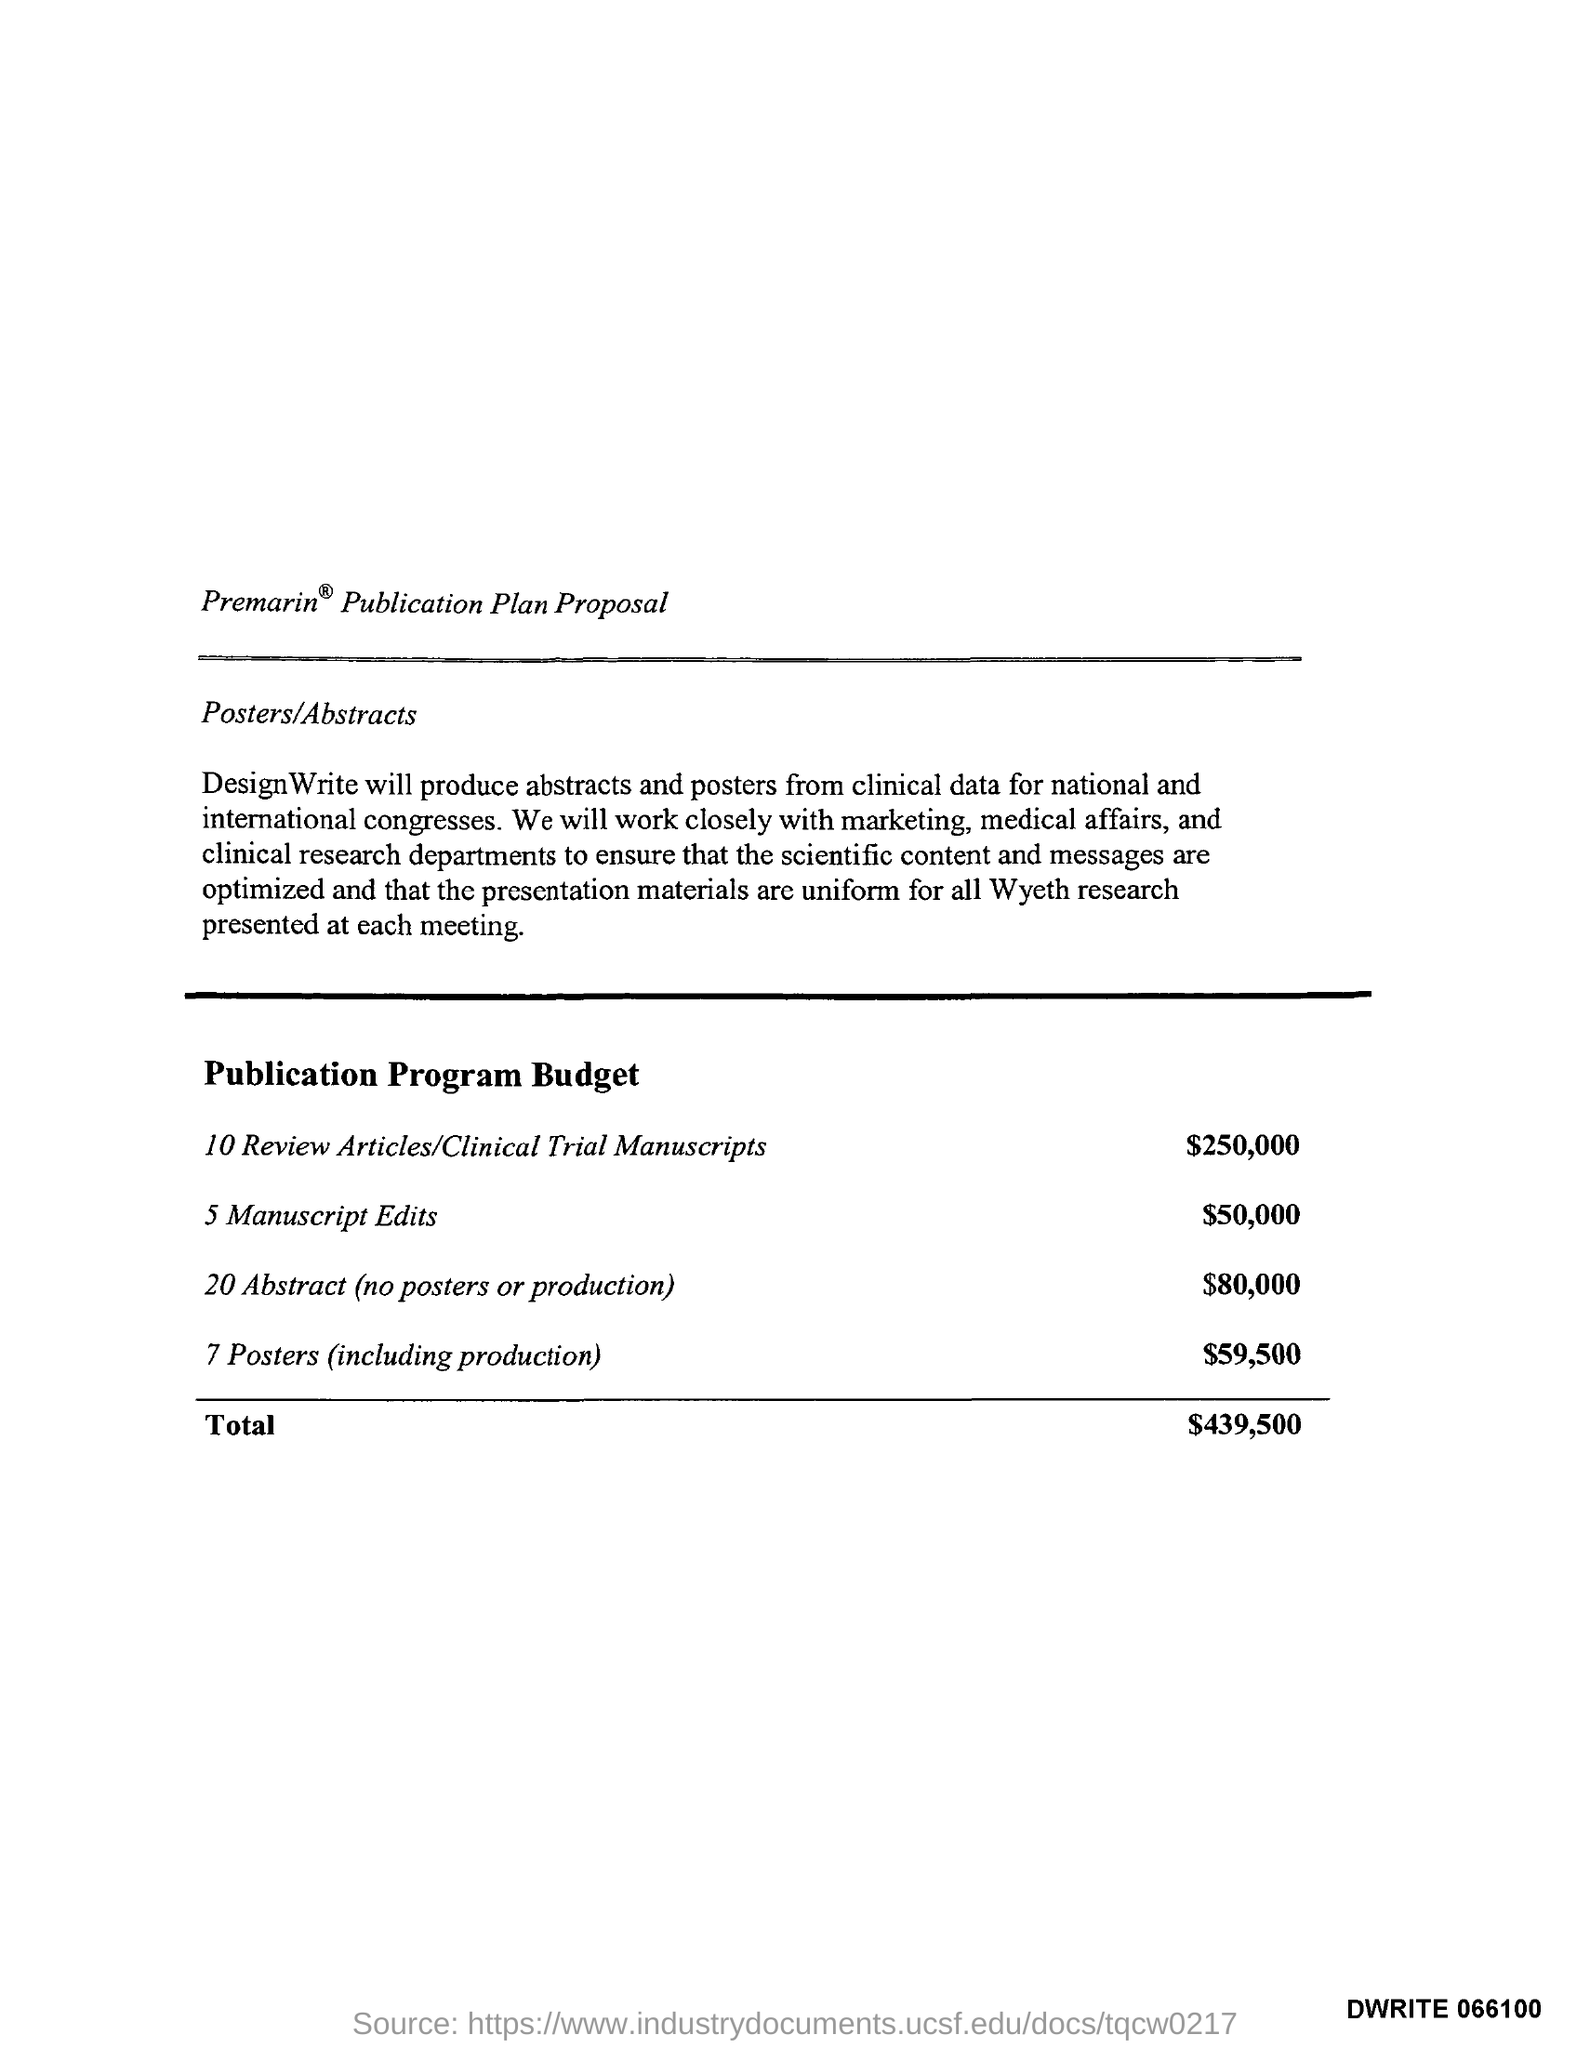Who produces abstract and posters from clinical data for national and international Congresses?
Offer a very short reply. Design Write. 